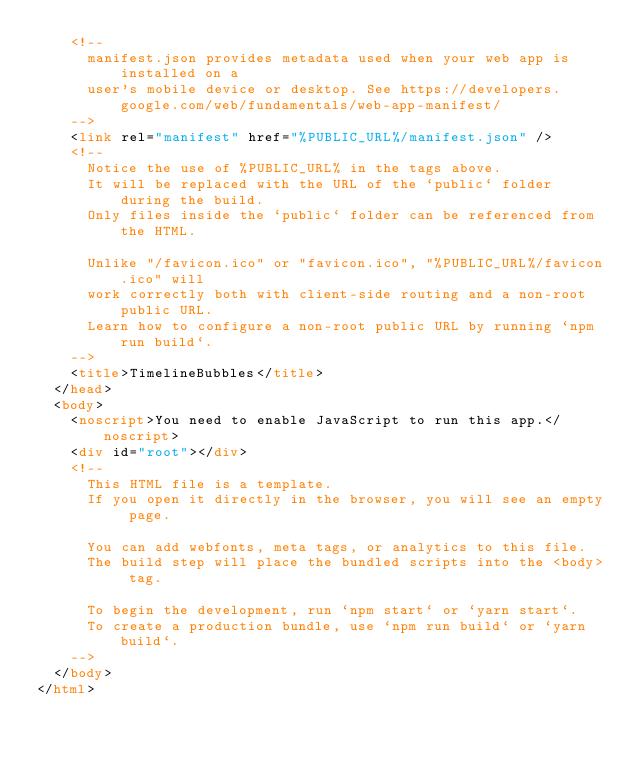<code> <loc_0><loc_0><loc_500><loc_500><_HTML_>    <!--
      manifest.json provides metadata used when your web app is installed on a
      user's mobile device or desktop. See https://developers.google.com/web/fundamentals/web-app-manifest/
    -->
    <link rel="manifest" href="%PUBLIC_URL%/manifest.json" />
    <!--
      Notice the use of %PUBLIC_URL% in the tags above.
      It will be replaced with the URL of the `public` folder during the build.
      Only files inside the `public` folder can be referenced from the HTML.

      Unlike "/favicon.ico" or "favicon.ico", "%PUBLIC_URL%/favicon.ico" will
      work correctly both with client-side routing and a non-root public URL.
      Learn how to configure a non-root public URL by running `npm run build`.
    -->
    <title>TimelineBubbles</title>
  </head>
  <body>
    <noscript>You need to enable JavaScript to run this app.</noscript>
    <div id="root"></div>
    <!--
      This HTML file is a template.
      If you open it directly in the browser, you will see an empty page.

      You can add webfonts, meta tags, or analytics to this file.
      The build step will place the bundled scripts into the <body> tag.

      To begin the development, run `npm start` or `yarn start`.
      To create a production bundle, use `npm run build` or `yarn build`.
    -->
  </body>
</html>
</code> 